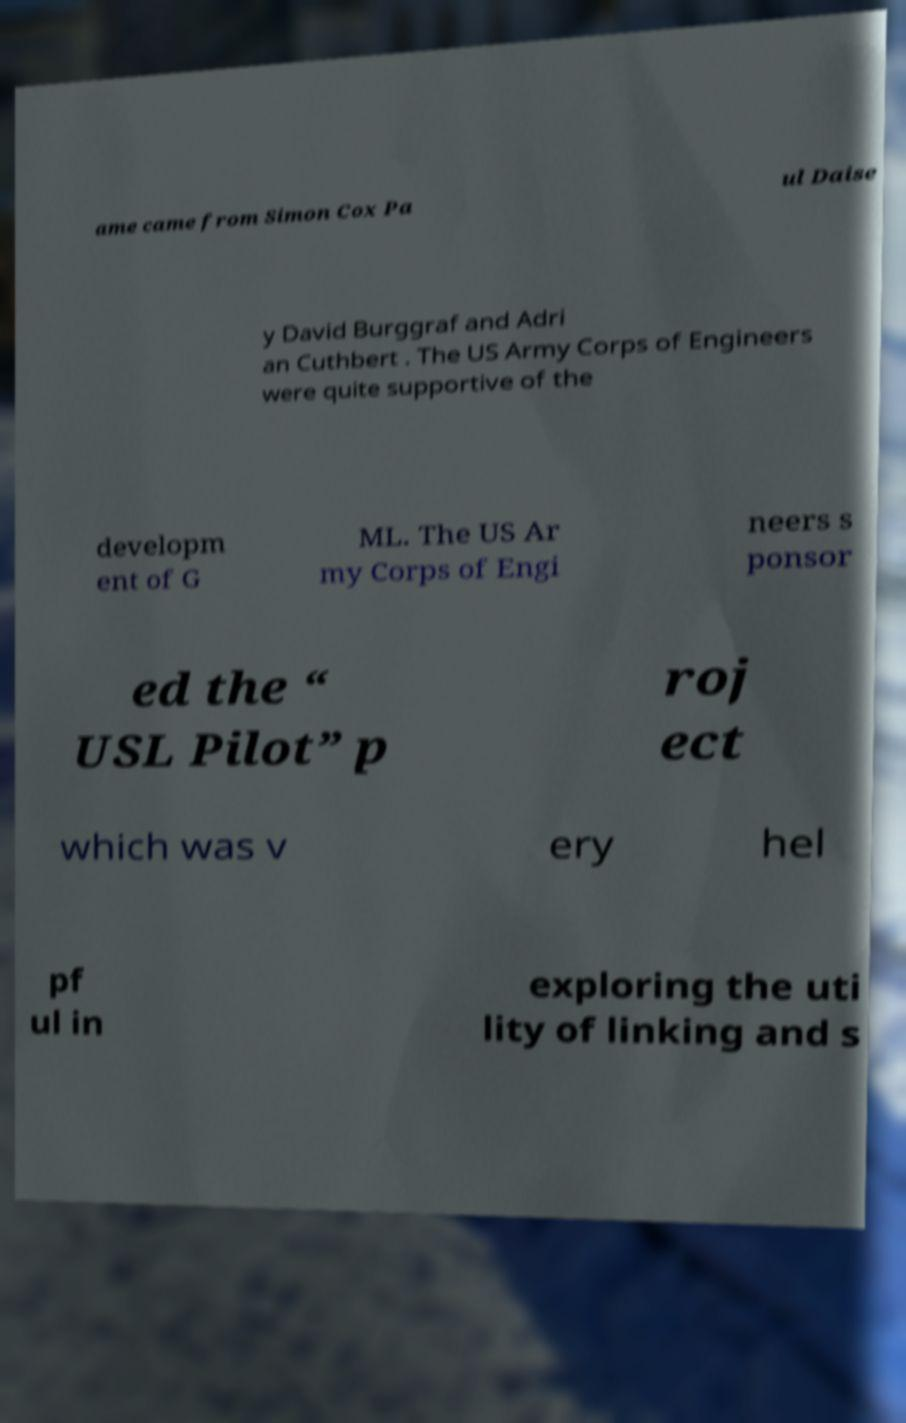What messages or text are displayed in this image? I need them in a readable, typed format. ame came from Simon Cox Pa ul Daise y David Burggraf and Adri an Cuthbert . The US Army Corps of Engineers were quite supportive of the developm ent of G ML. The US Ar my Corps of Engi neers s ponsor ed the “ USL Pilot” p roj ect which was v ery hel pf ul in exploring the uti lity of linking and s 